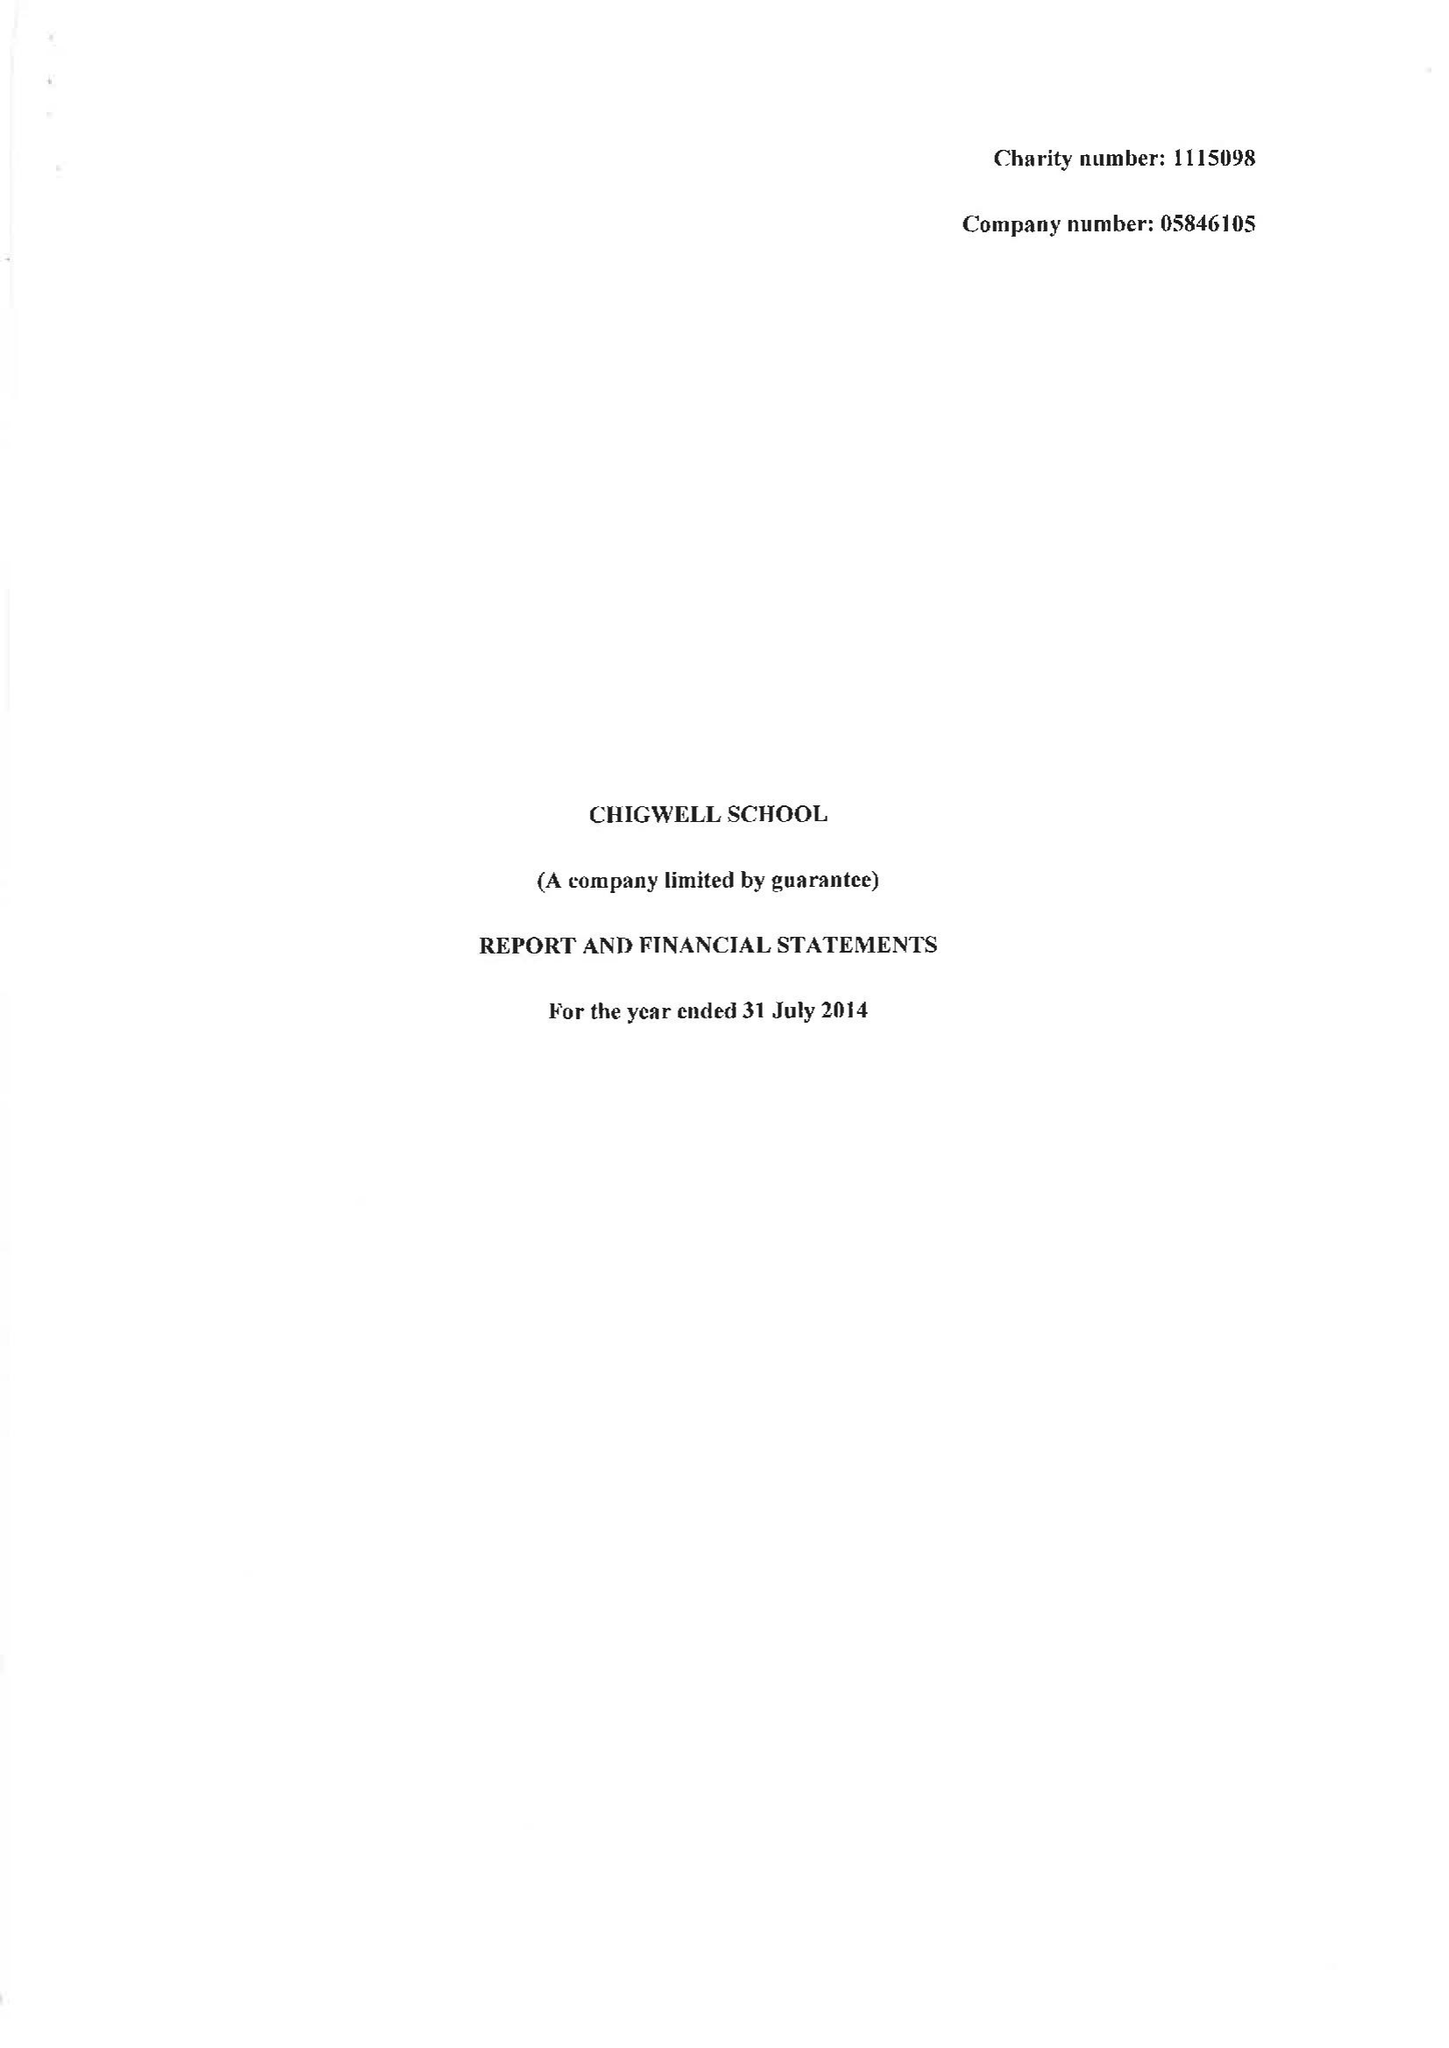What is the value for the charity_name?
Answer the question using a single word or phrase. Chigwell School 